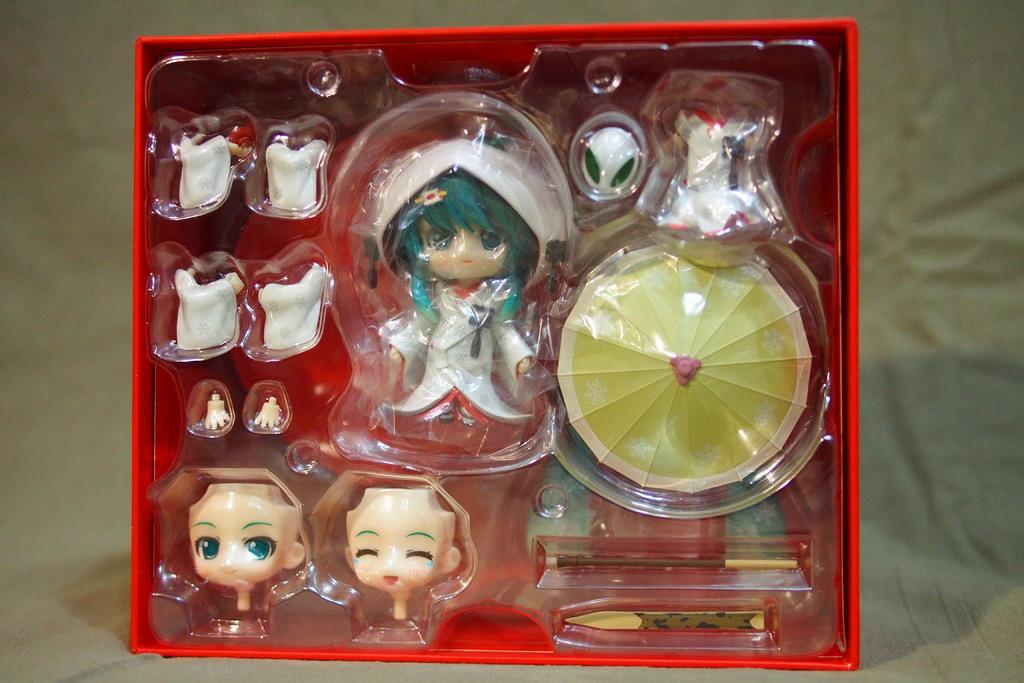What is the main object in the image? There is a box in the image. What is inside the box? The box contains toys. What type of sound can be heard coming from the box in the image? There is no sound coming from the box in the image, as it only contains toys and does not have any audible features. 